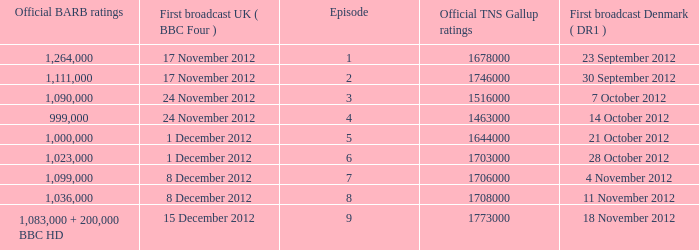What is the BARB ratings of episode 6? 1023000.0. 